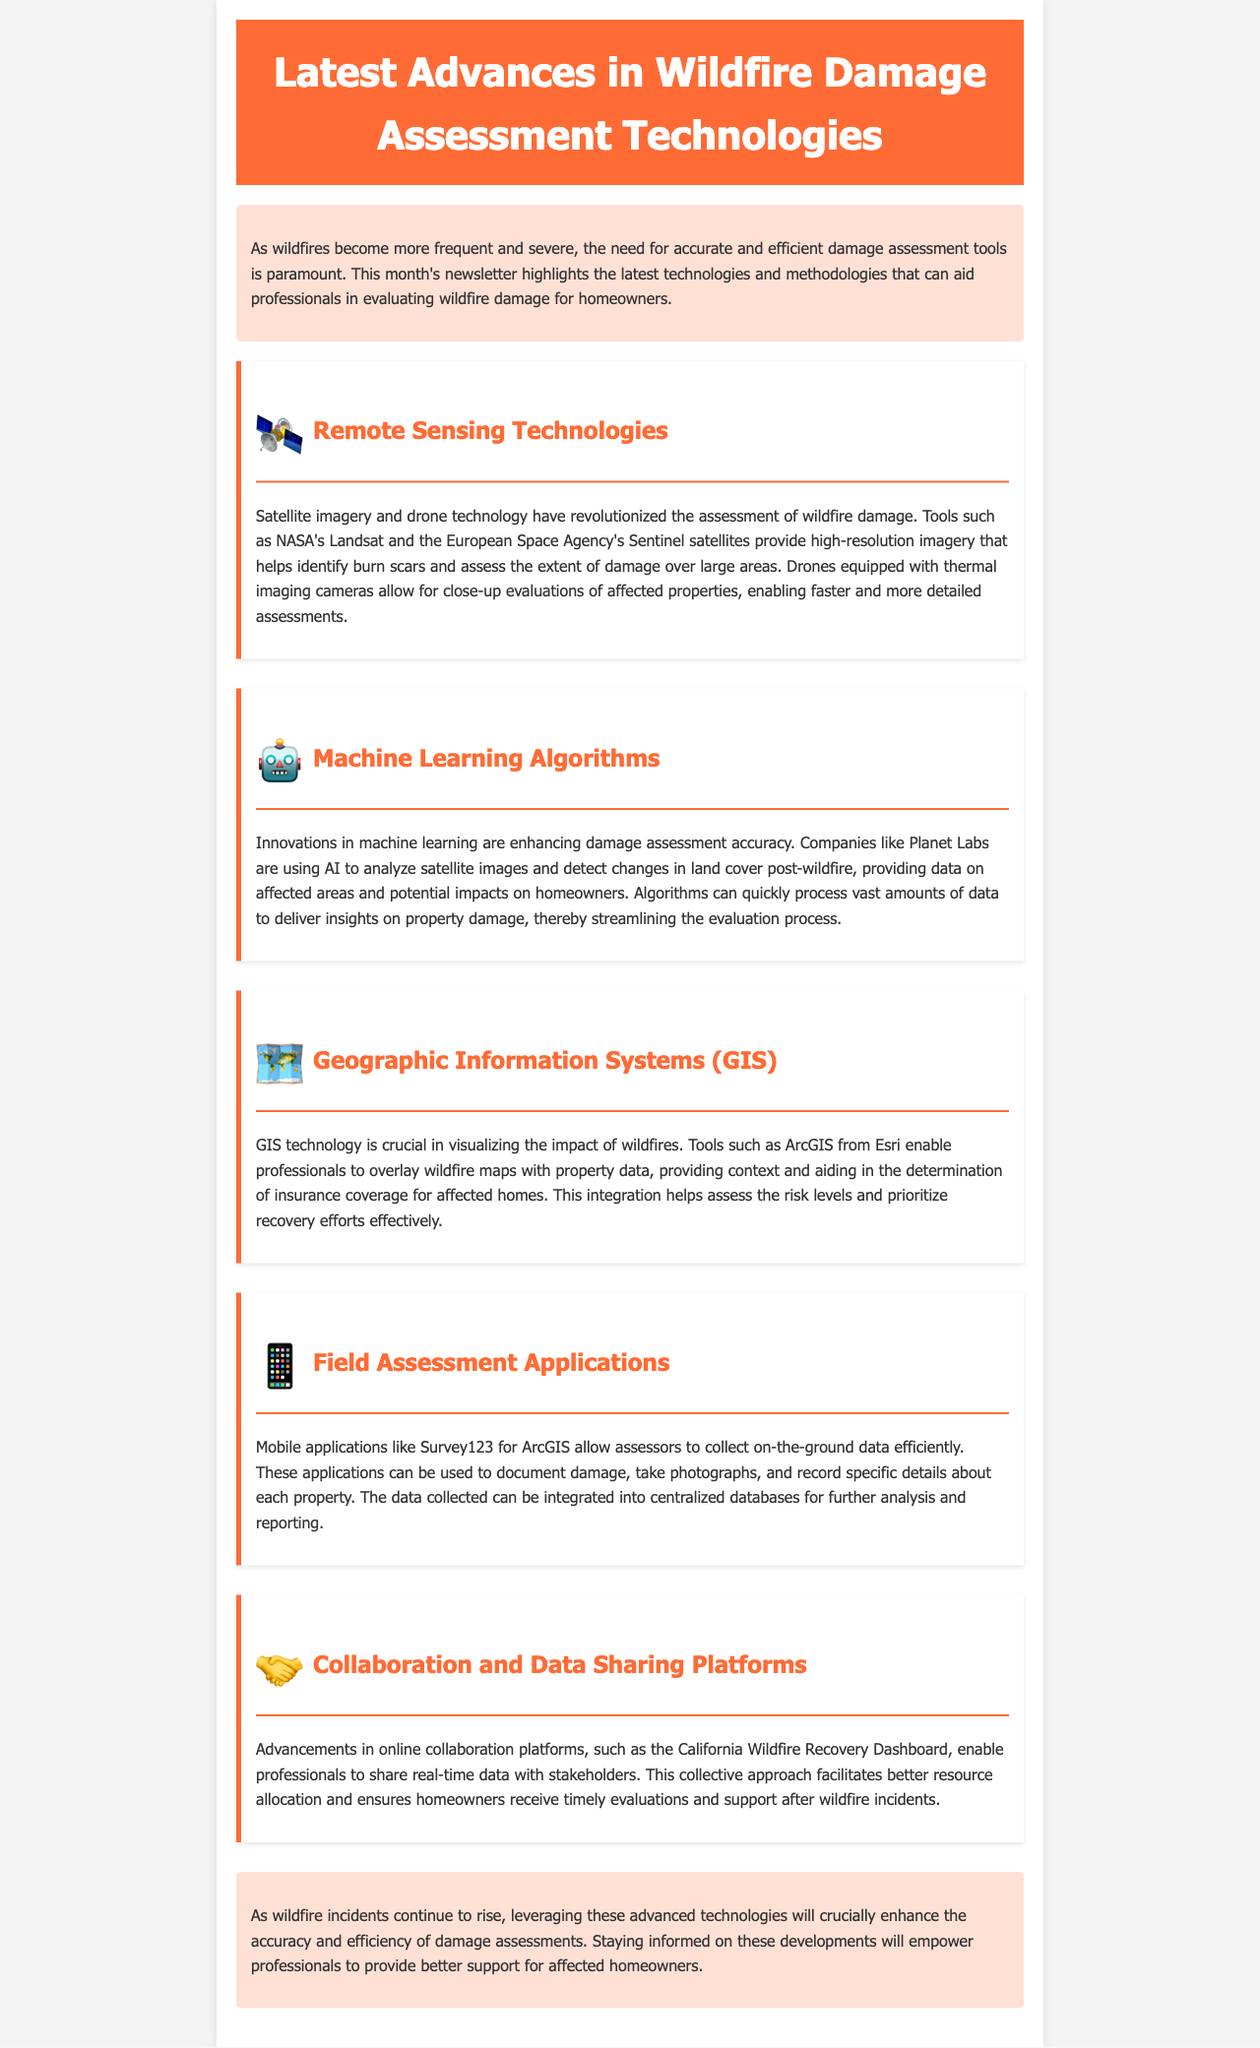What is the focus of this newsletter? The newsletter highlights the latest technologies and methodologies that can aid professionals in evaluating wildfire damage for homeowners.
Answer: Evaluating wildfire damage for homeowners Which technology allows for close-up evaluations of affected properties? Drones equipped with thermal imaging cameras allow for close-up evaluations, enabling faster and more detailed assessments.
Answer: Drones What is the name of the platform mentioned for data sharing? The California Wildfire Recovery Dashboard enables professionals to share real-time data with stakeholders.
Answer: California Wildfire Recovery Dashboard Who is using AI to analyze satellite images for damage assessment? Companies like Planet Labs are using AI to analyze satellite images and detect changes in land cover post-wildfire.
Answer: Planet Labs What technology is essential for visualizing the impact of wildfires? GIS technology is crucial in visualizing the impact of wildfires.
Answer: GIS technology How do mobile applications help field assessors? Mobile applications like Survey123 for ArcGIS allow assessors to collect on-the-ground data efficiently, document damage, and record specific details about properties.
Answer: Collect data efficiently What satellite programs are mentioned for damage assessment? NASA's Landsat and the European Space Agency's Sentinel satellites provide high-resolution imagery for damage assessment.
Answer: Landsat and Sentinel Why is staying informed on advanced technologies important for professionals? Staying informed on these developments will empower professionals to provide better support for affected homeowners.
Answer: Better support for affected homeowners 